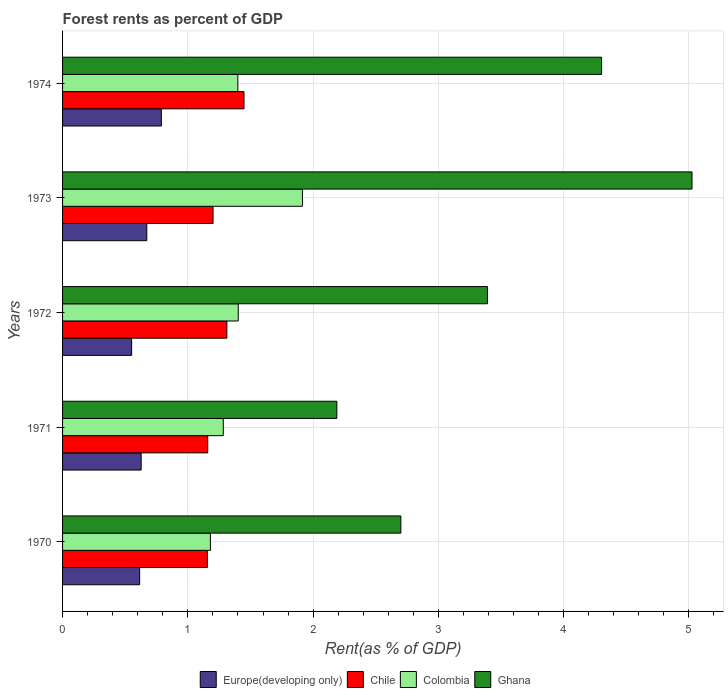How many groups of bars are there?
Offer a very short reply. 5. Are the number of bars per tick equal to the number of legend labels?
Ensure brevity in your answer.  Yes. How many bars are there on the 3rd tick from the top?
Provide a short and direct response. 4. What is the label of the 1st group of bars from the top?
Give a very brief answer. 1974. What is the forest rent in Ghana in 1970?
Make the answer very short. 2.7. Across all years, what is the maximum forest rent in Colombia?
Offer a very short reply. 1.92. Across all years, what is the minimum forest rent in Ghana?
Your answer should be very brief. 2.19. In which year was the forest rent in Chile maximum?
Make the answer very short. 1974. What is the total forest rent in Europe(developing only) in the graph?
Make the answer very short. 3.26. What is the difference between the forest rent in Colombia in 1971 and that in 1972?
Keep it short and to the point. -0.12. What is the difference between the forest rent in Ghana in 1970 and the forest rent in Europe(developing only) in 1974?
Give a very brief answer. 1.91. What is the average forest rent in Ghana per year?
Provide a short and direct response. 3.52. In the year 1971, what is the difference between the forest rent in Chile and forest rent in Ghana?
Your response must be concise. -1.03. What is the ratio of the forest rent in Europe(developing only) in 1970 to that in 1971?
Ensure brevity in your answer.  0.98. Is the forest rent in Chile in 1971 less than that in 1974?
Keep it short and to the point. Yes. Is the difference between the forest rent in Chile in 1973 and 1974 greater than the difference between the forest rent in Ghana in 1973 and 1974?
Ensure brevity in your answer.  No. What is the difference between the highest and the second highest forest rent in Chile?
Your answer should be compact. 0.14. What is the difference between the highest and the lowest forest rent in Colombia?
Your answer should be very brief. 0.73. In how many years, is the forest rent in Ghana greater than the average forest rent in Ghana taken over all years?
Offer a very short reply. 2. What does the 4th bar from the top in 1970 represents?
Your answer should be compact. Europe(developing only). What does the 1st bar from the bottom in 1970 represents?
Your answer should be very brief. Europe(developing only). Are all the bars in the graph horizontal?
Offer a terse response. Yes. How many years are there in the graph?
Your response must be concise. 5. Are the values on the major ticks of X-axis written in scientific E-notation?
Offer a very short reply. No. Does the graph contain grids?
Your answer should be compact. Yes. What is the title of the graph?
Provide a short and direct response. Forest rents as percent of GDP. Does "Guam" appear as one of the legend labels in the graph?
Provide a succinct answer. No. What is the label or title of the X-axis?
Give a very brief answer. Rent(as % of GDP). What is the Rent(as % of GDP) of Europe(developing only) in 1970?
Your answer should be compact. 0.62. What is the Rent(as % of GDP) in Chile in 1970?
Your answer should be compact. 1.16. What is the Rent(as % of GDP) of Colombia in 1970?
Provide a short and direct response. 1.18. What is the Rent(as % of GDP) of Ghana in 1970?
Keep it short and to the point. 2.7. What is the Rent(as % of GDP) in Europe(developing only) in 1971?
Your answer should be compact. 0.63. What is the Rent(as % of GDP) of Chile in 1971?
Your answer should be very brief. 1.16. What is the Rent(as % of GDP) of Colombia in 1971?
Give a very brief answer. 1.28. What is the Rent(as % of GDP) in Ghana in 1971?
Provide a short and direct response. 2.19. What is the Rent(as % of GDP) of Europe(developing only) in 1972?
Provide a succinct answer. 0.55. What is the Rent(as % of GDP) in Chile in 1972?
Keep it short and to the point. 1.31. What is the Rent(as % of GDP) in Colombia in 1972?
Keep it short and to the point. 1.4. What is the Rent(as % of GDP) of Ghana in 1972?
Provide a succinct answer. 3.39. What is the Rent(as % of GDP) in Europe(developing only) in 1973?
Make the answer very short. 0.67. What is the Rent(as % of GDP) in Chile in 1973?
Provide a succinct answer. 1.2. What is the Rent(as % of GDP) in Colombia in 1973?
Your response must be concise. 1.92. What is the Rent(as % of GDP) of Ghana in 1973?
Make the answer very short. 5.02. What is the Rent(as % of GDP) of Europe(developing only) in 1974?
Keep it short and to the point. 0.79. What is the Rent(as % of GDP) of Chile in 1974?
Keep it short and to the point. 1.45. What is the Rent(as % of GDP) of Colombia in 1974?
Your answer should be compact. 1.4. What is the Rent(as % of GDP) of Ghana in 1974?
Your answer should be very brief. 4.3. Across all years, what is the maximum Rent(as % of GDP) in Europe(developing only)?
Offer a terse response. 0.79. Across all years, what is the maximum Rent(as % of GDP) of Chile?
Provide a succinct answer. 1.45. Across all years, what is the maximum Rent(as % of GDP) of Colombia?
Make the answer very short. 1.92. Across all years, what is the maximum Rent(as % of GDP) in Ghana?
Offer a terse response. 5.02. Across all years, what is the minimum Rent(as % of GDP) in Europe(developing only)?
Make the answer very short. 0.55. Across all years, what is the minimum Rent(as % of GDP) in Chile?
Offer a terse response. 1.16. Across all years, what is the minimum Rent(as % of GDP) in Colombia?
Offer a very short reply. 1.18. Across all years, what is the minimum Rent(as % of GDP) of Ghana?
Your answer should be very brief. 2.19. What is the total Rent(as % of GDP) of Europe(developing only) in the graph?
Your response must be concise. 3.26. What is the total Rent(as % of GDP) in Chile in the graph?
Keep it short and to the point. 6.28. What is the total Rent(as % of GDP) in Colombia in the graph?
Offer a very short reply. 7.18. What is the total Rent(as % of GDP) of Ghana in the graph?
Your response must be concise. 17.61. What is the difference between the Rent(as % of GDP) of Europe(developing only) in 1970 and that in 1971?
Offer a very short reply. -0.01. What is the difference between the Rent(as % of GDP) in Chile in 1970 and that in 1971?
Provide a succinct answer. -0. What is the difference between the Rent(as % of GDP) in Colombia in 1970 and that in 1971?
Provide a short and direct response. -0.1. What is the difference between the Rent(as % of GDP) of Ghana in 1970 and that in 1971?
Provide a short and direct response. 0.51. What is the difference between the Rent(as % of GDP) in Europe(developing only) in 1970 and that in 1972?
Offer a terse response. 0.06. What is the difference between the Rent(as % of GDP) in Chile in 1970 and that in 1972?
Give a very brief answer. -0.16. What is the difference between the Rent(as % of GDP) of Colombia in 1970 and that in 1972?
Ensure brevity in your answer.  -0.22. What is the difference between the Rent(as % of GDP) in Ghana in 1970 and that in 1972?
Keep it short and to the point. -0.69. What is the difference between the Rent(as % of GDP) in Europe(developing only) in 1970 and that in 1973?
Offer a terse response. -0.06. What is the difference between the Rent(as % of GDP) of Chile in 1970 and that in 1973?
Provide a short and direct response. -0.05. What is the difference between the Rent(as % of GDP) in Colombia in 1970 and that in 1973?
Offer a very short reply. -0.73. What is the difference between the Rent(as % of GDP) in Ghana in 1970 and that in 1973?
Offer a terse response. -2.32. What is the difference between the Rent(as % of GDP) of Europe(developing only) in 1970 and that in 1974?
Your response must be concise. -0.17. What is the difference between the Rent(as % of GDP) of Chile in 1970 and that in 1974?
Your answer should be very brief. -0.29. What is the difference between the Rent(as % of GDP) of Colombia in 1970 and that in 1974?
Offer a terse response. -0.22. What is the difference between the Rent(as % of GDP) of Ghana in 1970 and that in 1974?
Your answer should be compact. -1.6. What is the difference between the Rent(as % of GDP) in Europe(developing only) in 1971 and that in 1972?
Provide a short and direct response. 0.08. What is the difference between the Rent(as % of GDP) of Chile in 1971 and that in 1972?
Offer a terse response. -0.15. What is the difference between the Rent(as % of GDP) of Colombia in 1971 and that in 1972?
Make the answer very short. -0.12. What is the difference between the Rent(as % of GDP) of Ghana in 1971 and that in 1972?
Your answer should be very brief. -1.2. What is the difference between the Rent(as % of GDP) of Europe(developing only) in 1971 and that in 1973?
Offer a very short reply. -0.05. What is the difference between the Rent(as % of GDP) in Chile in 1971 and that in 1973?
Offer a very short reply. -0.04. What is the difference between the Rent(as % of GDP) in Colombia in 1971 and that in 1973?
Offer a terse response. -0.63. What is the difference between the Rent(as % of GDP) of Ghana in 1971 and that in 1973?
Provide a short and direct response. -2.84. What is the difference between the Rent(as % of GDP) of Europe(developing only) in 1971 and that in 1974?
Offer a very short reply. -0.16. What is the difference between the Rent(as % of GDP) of Chile in 1971 and that in 1974?
Your answer should be compact. -0.29. What is the difference between the Rent(as % of GDP) of Colombia in 1971 and that in 1974?
Provide a succinct answer. -0.12. What is the difference between the Rent(as % of GDP) in Ghana in 1971 and that in 1974?
Make the answer very short. -2.11. What is the difference between the Rent(as % of GDP) in Europe(developing only) in 1972 and that in 1973?
Offer a very short reply. -0.12. What is the difference between the Rent(as % of GDP) in Chile in 1972 and that in 1973?
Your answer should be compact. 0.11. What is the difference between the Rent(as % of GDP) in Colombia in 1972 and that in 1973?
Make the answer very short. -0.51. What is the difference between the Rent(as % of GDP) in Ghana in 1972 and that in 1973?
Provide a short and direct response. -1.63. What is the difference between the Rent(as % of GDP) of Europe(developing only) in 1972 and that in 1974?
Your answer should be very brief. -0.24. What is the difference between the Rent(as % of GDP) in Chile in 1972 and that in 1974?
Your answer should be very brief. -0.14. What is the difference between the Rent(as % of GDP) of Colombia in 1972 and that in 1974?
Ensure brevity in your answer.  0. What is the difference between the Rent(as % of GDP) in Ghana in 1972 and that in 1974?
Your answer should be very brief. -0.91. What is the difference between the Rent(as % of GDP) of Europe(developing only) in 1973 and that in 1974?
Your response must be concise. -0.12. What is the difference between the Rent(as % of GDP) of Chile in 1973 and that in 1974?
Provide a short and direct response. -0.25. What is the difference between the Rent(as % of GDP) of Colombia in 1973 and that in 1974?
Make the answer very short. 0.52. What is the difference between the Rent(as % of GDP) in Ghana in 1973 and that in 1974?
Your answer should be very brief. 0.72. What is the difference between the Rent(as % of GDP) in Europe(developing only) in 1970 and the Rent(as % of GDP) in Chile in 1971?
Give a very brief answer. -0.54. What is the difference between the Rent(as % of GDP) in Europe(developing only) in 1970 and the Rent(as % of GDP) in Colombia in 1971?
Provide a short and direct response. -0.67. What is the difference between the Rent(as % of GDP) in Europe(developing only) in 1970 and the Rent(as % of GDP) in Ghana in 1971?
Ensure brevity in your answer.  -1.57. What is the difference between the Rent(as % of GDP) of Chile in 1970 and the Rent(as % of GDP) of Colombia in 1971?
Offer a terse response. -0.13. What is the difference between the Rent(as % of GDP) of Chile in 1970 and the Rent(as % of GDP) of Ghana in 1971?
Your answer should be compact. -1.03. What is the difference between the Rent(as % of GDP) of Colombia in 1970 and the Rent(as % of GDP) of Ghana in 1971?
Your answer should be compact. -1.01. What is the difference between the Rent(as % of GDP) in Europe(developing only) in 1970 and the Rent(as % of GDP) in Chile in 1972?
Offer a very short reply. -0.7. What is the difference between the Rent(as % of GDP) of Europe(developing only) in 1970 and the Rent(as % of GDP) of Colombia in 1972?
Give a very brief answer. -0.79. What is the difference between the Rent(as % of GDP) of Europe(developing only) in 1970 and the Rent(as % of GDP) of Ghana in 1972?
Your answer should be very brief. -2.78. What is the difference between the Rent(as % of GDP) in Chile in 1970 and the Rent(as % of GDP) in Colombia in 1972?
Make the answer very short. -0.25. What is the difference between the Rent(as % of GDP) of Chile in 1970 and the Rent(as % of GDP) of Ghana in 1972?
Provide a succinct answer. -2.24. What is the difference between the Rent(as % of GDP) of Colombia in 1970 and the Rent(as % of GDP) of Ghana in 1972?
Your answer should be very brief. -2.21. What is the difference between the Rent(as % of GDP) of Europe(developing only) in 1970 and the Rent(as % of GDP) of Chile in 1973?
Keep it short and to the point. -0.59. What is the difference between the Rent(as % of GDP) of Europe(developing only) in 1970 and the Rent(as % of GDP) of Colombia in 1973?
Your answer should be compact. -1.3. What is the difference between the Rent(as % of GDP) in Europe(developing only) in 1970 and the Rent(as % of GDP) in Ghana in 1973?
Your response must be concise. -4.41. What is the difference between the Rent(as % of GDP) of Chile in 1970 and the Rent(as % of GDP) of Colombia in 1973?
Offer a very short reply. -0.76. What is the difference between the Rent(as % of GDP) in Chile in 1970 and the Rent(as % of GDP) in Ghana in 1973?
Your response must be concise. -3.87. What is the difference between the Rent(as % of GDP) of Colombia in 1970 and the Rent(as % of GDP) of Ghana in 1973?
Offer a very short reply. -3.84. What is the difference between the Rent(as % of GDP) in Europe(developing only) in 1970 and the Rent(as % of GDP) in Chile in 1974?
Keep it short and to the point. -0.83. What is the difference between the Rent(as % of GDP) of Europe(developing only) in 1970 and the Rent(as % of GDP) of Colombia in 1974?
Offer a very short reply. -0.78. What is the difference between the Rent(as % of GDP) of Europe(developing only) in 1970 and the Rent(as % of GDP) of Ghana in 1974?
Give a very brief answer. -3.69. What is the difference between the Rent(as % of GDP) in Chile in 1970 and the Rent(as % of GDP) in Colombia in 1974?
Offer a terse response. -0.24. What is the difference between the Rent(as % of GDP) in Chile in 1970 and the Rent(as % of GDP) in Ghana in 1974?
Offer a very short reply. -3.15. What is the difference between the Rent(as % of GDP) in Colombia in 1970 and the Rent(as % of GDP) in Ghana in 1974?
Keep it short and to the point. -3.12. What is the difference between the Rent(as % of GDP) in Europe(developing only) in 1971 and the Rent(as % of GDP) in Chile in 1972?
Give a very brief answer. -0.68. What is the difference between the Rent(as % of GDP) in Europe(developing only) in 1971 and the Rent(as % of GDP) in Colombia in 1972?
Your answer should be very brief. -0.78. What is the difference between the Rent(as % of GDP) in Europe(developing only) in 1971 and the Rent(as % of GDP) in Ghana in 1972?
Offer a terse response. -2.76. What is the difference between the Rent(as % of GDP) in Chile in 1971 and the Rent(as % of GDP) in Colombia in 1972?
Your answer should be very brief. -0.24. What is the difference between the Rent(as % of GDP) in Chile in 1971 and the Rent(as % of GDP) in Ghana in 1972?
Make the answer very short. -2.23. What is the difference between the Rent(as % of GDP) of Colombia in 1971 and the Rent(as % of GDP) of Ghana in 1972?
Give a very brief answer. -2.11. What is the difference between the Rent(as % of GDP) of Europe(developing only) in 1971 and the Rent(as % of GDP) of Chile in 1973?
Provide a succinct answer. -0.57. What is the difference between the Rent(as % of GDP) in Europe(developing only) in 1971 and the Rent(as % of GDP) in Colombia in 1973?
Provide a succinct answer. -1.29. What is the difference between the Rent(as % of GDP) in Europe(developing only) in 1971 and the Rent(as % of GDP) in Ghana in 1973?
Provide a short and direct response. -4.4. What is the difference between the Rent(as % of GDP) in Chile in 1971 and the Rent(as % of GDP) in Colombia in 1973?
Make the answer very short. -0.76. What is the difference between the Rent(as % of GDP) in Chile in 1971 and the Rent(as % of GDP) in Ghana in 1973?
Your answer should be very brief. -3.87. What is the difference between the Rent(as % of GDP) of Colombia in 1971 and the Rent(as % of GDP) of Ghana in 1973?
Offer a terse response. -3.74. What is the difference between the Rent(as % of GDP) in Europe(developing only) in 1971 and the Rent(as % of GDP) in Chile in 1974?
Keep it short and to the point. -0.82. What is the difference between the Rent(as % of GDP) in Europe(developing only) in 1971 and the Rent(as % of GDP) in Colombia in 1974?
Ensure brevity in your answer.  -0.77. What is the difference between the Rent(as % of GDP) in Europe(developing only) in 1971 and the Rent(as % of GDP) in Ghana in 1974?
Your answer should be very brief. -3.68. What is the difference between the Rent(as % of GDP) of Chile in 1971 and the Rent(as % of GDP) of Colombia in 1974?
Give a very brief answer. -0.24. What is the difference between the Rent(as % of GDP) in Chile in 1971 and the Rent(as % of GDP) in Ghana in 1974?
Offer a terse response. -3.14. What is the difference between the Rent(as % of GDP) in Colombia in 1971 and the Rent(as % of GDP) in Ghana in 1974?
Offer a terse response. -3.02. What is the difference between the Rent(as % of GDP) in Europe(developing only) in 1972 and the Rent(as % of GDP) in Chile in 1973?
Your response must be concise. -0.65. What is the difference between the Rent(as % of GDP) in Europe(developing only) in 1972 and the Rent(as % of GDP) in Colombia in 1973?
Your answer should be compact. -1.36. What is the difference between the Rent(as % of GDP) in Europe(developing only) in 1972 and the Rent(as % of GDP) in Ghana in 1973?
Your response must be concise. -4.47. What is the difference between the Rent(as % of GDP) of Chile in 1972 and the Rent(as % of GDP) of Colombia in 1973?
Keep it short and to the point. -0.6. What is the difference between the Rent(as % of GDP) in Chile in 1972 and the Rent(as % of GDP) in Ghana in 1973?
Your response must be concise. -3.71. What is the difference between the Rent(as % of GDP) in Colombia in 1972 and the Rent(as % of GDP) in Ghana in 1973?
Offer a very short reply. -3.62. What is the difference between the Rent(as % of GDP) in Europe(developing only) in 1972 and the Rent(as % of GDP) in Chile in 1974?
Your answer should be very brief. -0.9. What is the difference between the Rent(as % of GDP) of Europe(developing only) in 1972 and the Rent(as % of GDP) of Colombia in 1974?
Your answer should be compact. -0.85. What is the difference between the Rent(as % of GDP) of Europe(developing only) in 1972 and the Rent(as % of GDP) of Ghana in 1974?
Your answer should be very brief. -3.75. What is the difference between the Rent(as % of GDP) of Chile in 1972 and the Rent(as % of GDP) of Colombia in 1974?
Your response must be concise. -0.09. What is the difference between the Rent(as % of GDP) in Chile in 1972 and the Rent(as % of GDP) in Ghana in 1974?
Provide a succinct answer. -2.99. What is the difference between the Rent(as % of GDP) in Colombia in 1972 and the Rent(as % of GDP) in Ghana in 1974?
Keep it short and to the point. -2.9. What is the difference between the Rent(as % of GDP) in Europe(developing only) in 1973 and the Rent(as % of GDP) in Chile in 1974?
Provide a short and direct response. -0.78. What is the difference between the Rent(as % of GDP) in Europe(developing only) in 1973 and the Rent(as % of GDP) in Colombia in 1974?
Your response must be concise. -0.73. What is the difference between the Rent(as % of GDP) of Europe(developing only) in 1973 and the Rent(as % of GDP) of Ghana in 1974?
Give a very brief answer. -3.63. What is the difference between the Rent(as % of GDP) in Chile in 1973 and the Rent(as % of GDP) in Colombia in 1974?
Your answer should be very brief. -0.2. What is the difference between the Rent(as % of GDP) of Chile in 1973 and the Rent(as % of GDP) of Ghana in 1974?
Keep it short and to the point. -3.1. What is the difference between the Rent(as % of GDP) of Colombia in 1973 and the Rent(as % of GDP) of Ghana in 1974?
Your answer should be very brief. -2.39. What is the average Rent(as % of GDP) in Europe(developing only) per year?
Provide a succinct answer. 0.65. What is the average Rent(as % of GDP) of Chile per year?
Your answer should be very brief. 1.26. What is the average Rent(as % of GDP) in Colombia per year?
Ensure brevity in your answer.  1.44. What is the average Rent(as % of GDP) in Ghana per year?
Offer a very short reply. 3.52. In the year 1970, what is the difference between the Rent(as % of GDP) in Europe(developing only) and Rent(as % of GDP) in Chile?
Make the answer very short. -0.54. In the year 1970, what is the difference between the Rent(as % of GDP) of Europe(developing only) and Rent(as % of GDP) of Colombia?
Your answer should be compact. -0.56. In the year 1970, what is the difference between the Rent(as % of GDP) of Europe(developing only) and Rent(as % of GDP) of Ghana?
Keep it short and to the point. -2.09. In the year 1970, what is the difference between the Rent(as % of GDP) of Chile and Rent(as % of GDP) of Colombia?
Keep it short and to the point. -0.02. In the year 1970, what is the difference between the Rent(as % of GDP) in Chile and Rent(as % of GDP) in Ghana?
Provide a short and direct response. -1.54. In the year 1970, what is the difference between the Rent(as % of GDP) in Colombia and Rent(as % of GDP) in Ghana?
Ensure brevity in your answer.  -1.52. In the year 1971, what is the difference between the Rent(as % of GDP) in Europe(developing only) and Rent(as % of GDP) in Chile?
Provide a short and direct response. -0.53. In the year 1971, what is the difference between the Rent(as % of GDP) in Europe(developing only) and Rent(as % of GDP) in Colombia?
Give a very brief answer. -0.66. In the year 1971, what is the difference between the Rent(as % of GDP) of Europe(developing only) and Rent(as % of GDP) of Ghana?
Provide a short and direct response. -1.56. In the year 1971, what is the difference between the Rent(as % of GDP) of Chile and Rent(as % of GDP) of Colombia?
Your response must be concise. -0.12. In the year 1971, what is the difference between the Rent(as % of GDP) in Chile and Rent(as % of GDP) in Ghana?
Give a very brief answer. -1.03. In the year 1971, what is the difference between the Rent(as % of GDP) of Colombia and Rent(as % of GDP) of Ghana?
Your answer should be compact. -0.91. In the year 1972, what is the difference between the Rent(as % of GDP) in Europe(developing only) and Rent(as % of GDP) in Chile?
Give a very brief answer. -0.76. In the year 1972, what is the difference between the Rent(as % of GDP) in Europe(developing only) and Rent(as % of GDP) in Colombia?
Keep it short and to the point. -0.85. In the year 1972, what is the difference between the Rent(as % of GDP) of Europe(developing only) and Rent(as % of GDP) of Ghana?
Provide a short and direct response. -2.84. In the year 1972, what is the difference between the Rent(as % of GDP) in Chile and Rent(as % of GDP) in Colombia?
Ensure brevity in your answer.  -0.09. In the year 1972, what is the difference between the Rent(as % of GDP) of Chile and Rent(as % of GDP) of Ghana?
Make the answer very short. -2.08. In the year 1972, what is the difference between the Rent(as % of GDP) in Colombia and Rent(as % of GDP) in Ghana?
Offer a terse response. -1.99. In the year 1973, what is the difference between the Rent(as % of GDP) of Europe(developing only) and Rent(as % of GDP) of Chile?
Provide a short and direct response. -0.53. In the year 1973, what is the difference between the Rent(as % of GDP) of Europe(developing only) and Rent(as % of GDP) of Colombia?
Provide a short and direct response. -1.24. In the year 1973, what is the difference between the Rent(as % of GDP) of Europe(developing only) and Rent(as % of GDP) of Ghana?
Ensure brevity in your answer.  -4.35. In the year 1973, what is the difference between the Rent(as % of GDP) in Chile and Rent(as % of GDP) in Colombia?
Your answer should be compact. -0.71. In the year 1973, what is the difference between the Rent(as % of GDP) in Chile and Rent(as % of GDP) in Ghana?
Ensure brevity in your answer.  -3.82. In the year 1973, what is the difference between the Rent(as % of GDP) in Colombia and Rent(as % of GDP) in Ghana?
Offer a terse response. -3.11. In the year 1974, what is the difference between the Rent(as % of GDP) in Europe(developing only) and Rent(as % of GDP) in Chile?
Ensure brevity in your answer.  -0.66. In the year 1974, what is the difference between the Rent(as % of GDP) of Europe(developing only) and Rent(as % of GDP) of Colombia?
Ensure brevity in your answer.  -0.61. In the year 1974, what is the difference between the Rent(as % of GDP) of Europe(developing only) and Rent(as % of GDP) of Ghana?
Your answer should be compact. -3.51. In the year 1974, what is the difference between the Rent(as % of GDP) of Chile and Rent(as % of GDP) of Colombia?
Provide a succinct answer. 0.05. In the year 1974, what is the difference between the Rent(as % of GDP) in Chile and Rent(as % of GDP) in Ghana?
Offer a terse response. -2.85. In the year 1974, what is the difference between the Rent(as % of GDP) in Colombia and Rent(as % of GDP) in Ghana?
Offer a terse response. -2.9. What is the ratio of the Rent(as % of GDP) of Europe(developing only) in 1970 to that in 1971?
Offer a very short reply. 0.98. What is the ratio of the Rent(as % of GDP) of Colombia in 1970 to that in 1971?
Give a very brief answer. 0.92. What is the ratio of the Rent(as % of GDP) of Ghana in 1970 to that in 1971?
Keep it short and to the point. 1.23. What is the ratio of the Rent(as % of GDP) of Europe(developing only) in 1970 to that in 1972?
Give a very brief answer. 1.12. What is the ratio of the Rent(as % of GDP) in Chile in 1970 to that in 1972?
Offer a terse response. 0.88. What is the ratio of the Rent(as % of GDP) in Colombia in 1970 to that in 1972?
Your answer should be compact. 0.84. What is the ratio of the Rent(as % of GDP) of Ghana in 1970 to that in 1972?
Ensure brevity in your answer.  0.8. What is the ratio of the Rent(as % of GDP) of Europe(developing only) in 1970 to that in 1973?
Your answer should be compact. 0.92. What is the ratio of the Rent(as % of GDP) of Chile in 1970 to that in 1973?
Your answer should be compact. 0.96. What is the ratio of the Rent(as % of GDP) of Colombia in 1970 to that in 1973?
Make the answer very short. 0.62. What is the ratio of the Rent(as % of GDP) of Ghana in 1970 to that in 1973?
Offer a very short reply. 0.54. What is the ratio of the Rent(as % of GDP) of Europe(developing only) in 1970 to that in 1974?
Provide a succinct answer. 0.78. What is the ratio of the Rent(as % of GDP) in Chile in 1970 to that in 1974?
Offer a terse response. 0.8. What is the ratio of the Rent(as % of GDP) in Colombia in 1970 to that in 1974?
Offer a very short reply. 0.84. What is the ratio of the Rent(as % of GDP) in Ghana in 1970 to that in 1974?
Your answer should be very brief. 0.63. What is the ratio of the Rent(as % of GDP) in Europe(developing only) in 1971 to that in 1972?
Provide a succinct answer. 1.14. What is the ratio of the Rent(as % of GDP) of Chile in 1971 to that in 1972?
Give a very brief answer. 0.88. What is the ratio of the Rent(as % of GDP) in Colombia in 1971 to that in 1972?
Offer a terse response. 0.91. What is the ratio of the Rent(as % of GDP) of Ghana in 1971 to that in 1972?
Make the answer very short. 0.65. What is the ratio of the Rent(as % of GDP) of Europe(developing only) in 1971 to that in 1973?
Offer a very short reply. 0.93. What is the ratio of the Rent(as % of GDP) in Chile in 1971 to that in 1973?
Keep it short and to the point. 0.96. What is the ratio of the Rent(as % of GDP) in Colombia in 1971 to that in 1973?
Provide a succinct answer. 0.67. What is the ratio of the Rent(as % of GDP) of Ghana in 1971 to that in 1973?
Give a very brief answer. 0.44. What is the ratio of the Rent(as % of GDP) of Europe(developing only) in 1971 to that in 1974?
Your answer should be very brief. 0.8. What is the ratio of the Rent(as % of GDP) of Chile in 1971 to that in 1974?
Offer a terse response. 0.8. What is the ratio of the Rent(as % of GDP) of Colombia in 1971 to that in 1974?
Make the answer very short. 0.92. What is the ratio of the Rent(as % of GDP) in Ghana in 1971 to that in 1974?
Your answer should be very brief. 0.51. What is the ratio of the Rent(as % of GDP) in Europe(developing only) in 1972 to that in 1973?
Offer a terse response. 0.82. What is the ratio of the Rent(as % of GDP) in Chile in 1972 to that in 1973?
Keep it short and to the point. 1.09. What is the ratio of the Rent(as % of GDP) in Colombia in 1972 to that in 1973?
Provide a succinct answer. 0.73. What is the ratio of the Rent(as % of GDP) of Ghana in 1972 to that in 1973?
Offer a very short reply. 0.68. What is the ratio of the Rent(as % of GDP) in Europe(developing only) in 1972 to that in 1974?
Give a very brief answer. 0.7. What is the ratio of the Rent(as % of GDP) of Chile in 1972 to that in 1974?
Your answer should be very brief. 0.91. What is the ratio of the Rent(as % of GDP) in Colombia in 1972 to that in 1974?
Ensure brevity in your answer.  1. What is the ratio of the Rent(as % of GDP) in Ghana in 1972 to that in 1974?
Keep it short and to the point. 0.79. What is the ratio of the Rent(as % of GDP) in Europe(developing only) in 1973 to that in 1974?
Provide a short and direct response. 0.85. What is the ratio of the Rent(as % of GDP) in Chile in 1973 to that in 1974?
Your response must be concise. 0.83. What is the ratio of the Rent(as % of GDP) of Colombia in 1973 to that in 1974?
Ensure brevity in your answer.  1.37. What is the ratio of the Rent(as % of GDP) of Ghana in 1973 to that in 1974?
Your answer should be compact. 1.17. What is the difference between the highest and the second highest Rent(as % of GDP) in Europe(developing only)?
Ensure brevity in your answer.  0.12. What is the difference between the highest and the second highest Rent(as % of GDP) of Chile?
Offer a terse response. 0.14. What is the difference between the highest and the second highest Rent(as % of GDP) in Colombia?
Offer a very short reply. 0.51. What is the difference between the highest and the second highest Rent(as % of GDP) in Ghana?
Provide a succinct answer. 0.72. What is the difference between the highest and the lowest Rent(as % of GDP) of Europe(developing only)?
Your response must be concise. 0.24. What is the difference between the highest and the lowest Rent(as % of GDP) of Chile?
Offer a terse response. 0.29. What is the difference between the highest and the lowest Rent(as % of GDP) of Colombia?
Provide a short and direct response. 0.73. What is the difference between the highest and the lowest Rent(as % of GDP) in Ghana?
Provide a short and direct response. 2.84. 